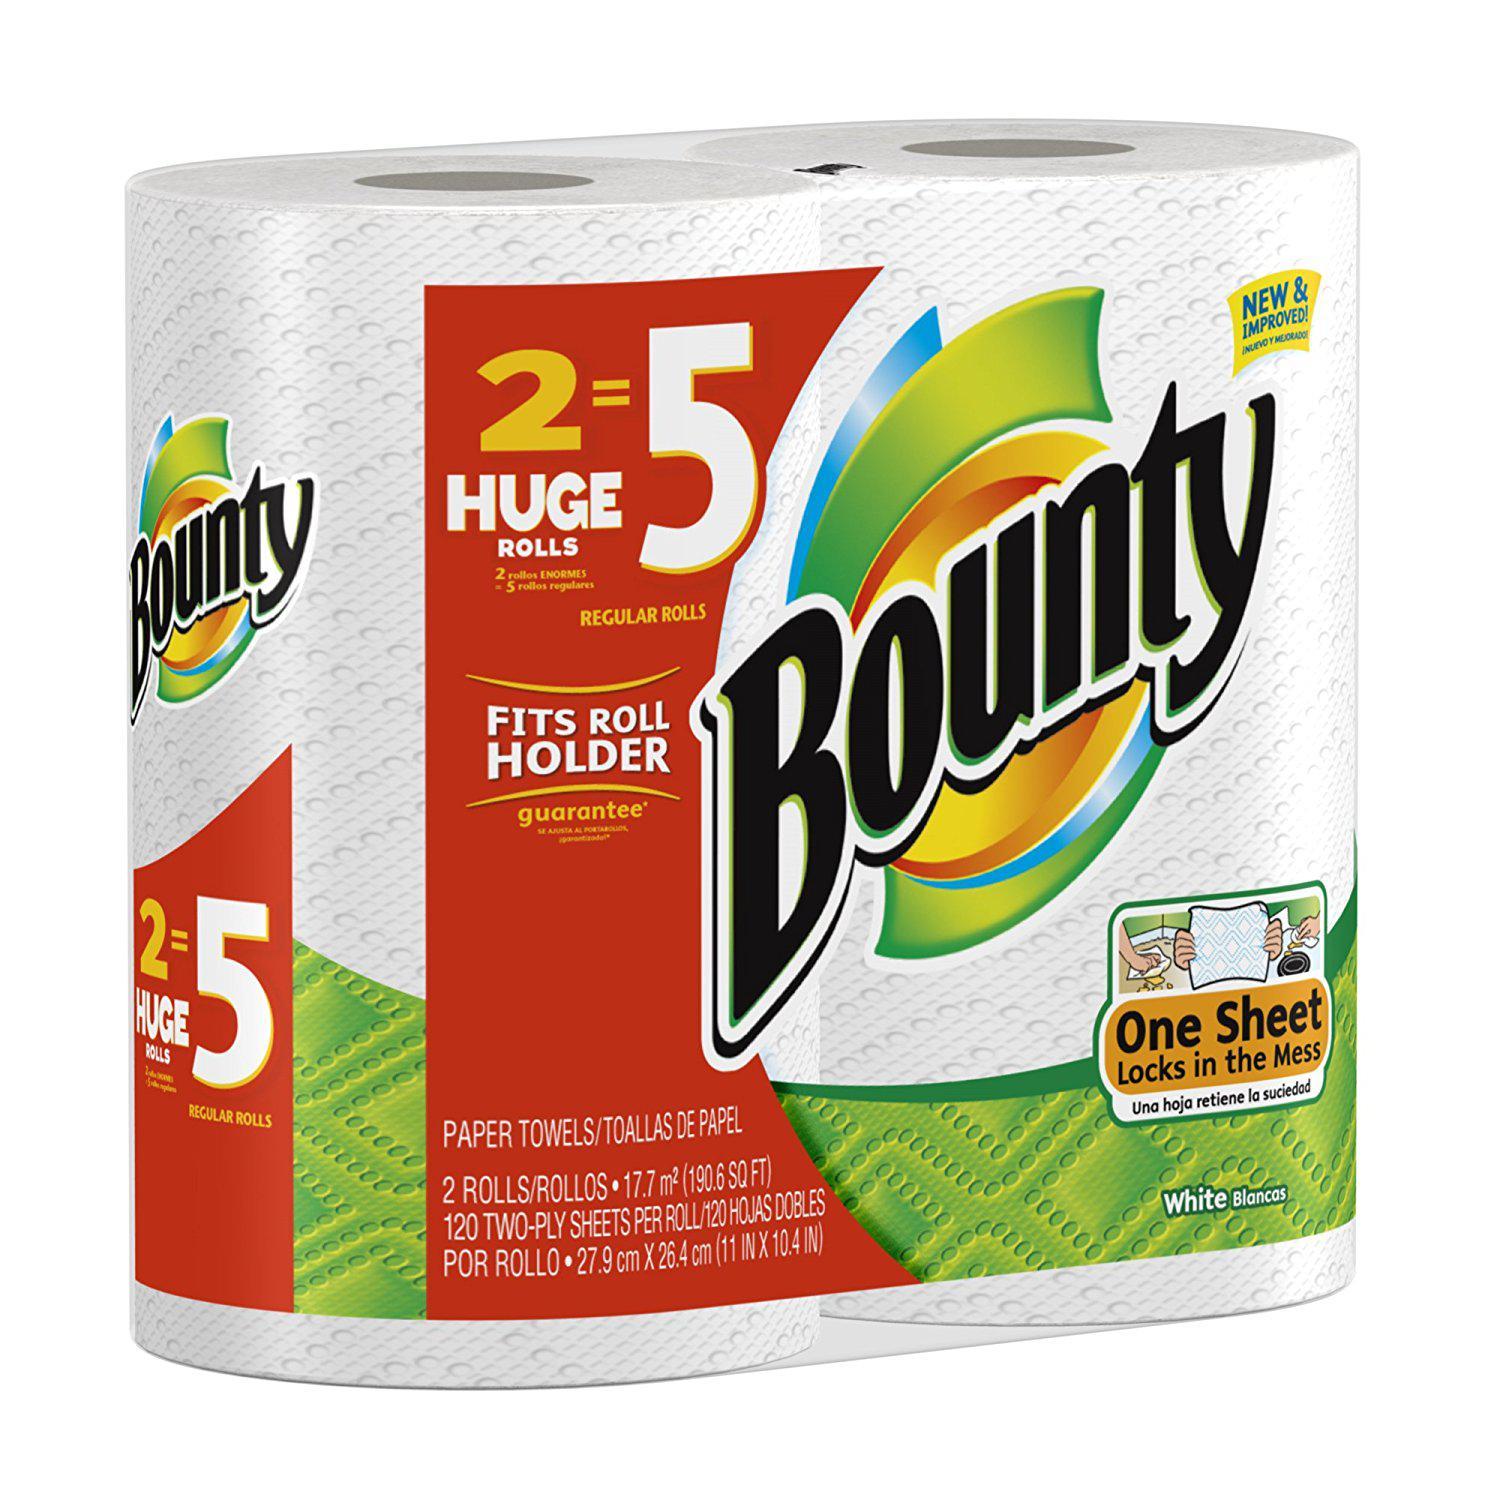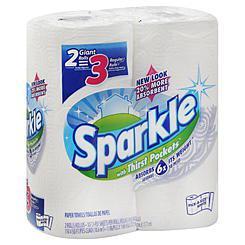The first image is the image on the left, the second image is the image on the right. Examine the images to the left and right. Is the description "Each image shows only a sealed package of paper towels and no package contains more than three rolls." accurate? Answer yes or no. Yes. The first image is the image on the left, the second image is the image on the right. Given the left and right images, does the statement "An image includes some amount of paper towel that is not in its wrapped package." hold true? Answer yes or no. No. 